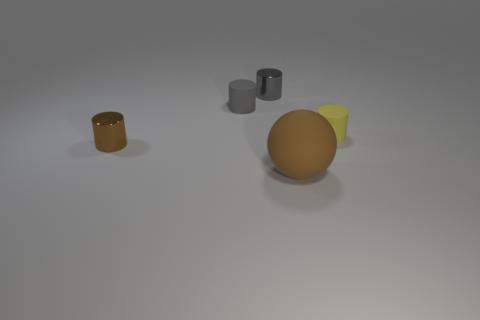Can you tell me what each of the objects in the image might be used for? While the image doesn't provide explicit details about the use of each object, we can make educated guesses. The two gray cylindrical objects might be containers or simply representational geometric shapes used for display or educational purposes. The larger spherical object could be a model used for visual arts, teaching geometry or physics concepts, and the yellow wedge might serve a similar educational purpose. The smaller orange-brown container could resemble a cup or pot, potentially used for holding items, although its specific function isn't clear without more context. 